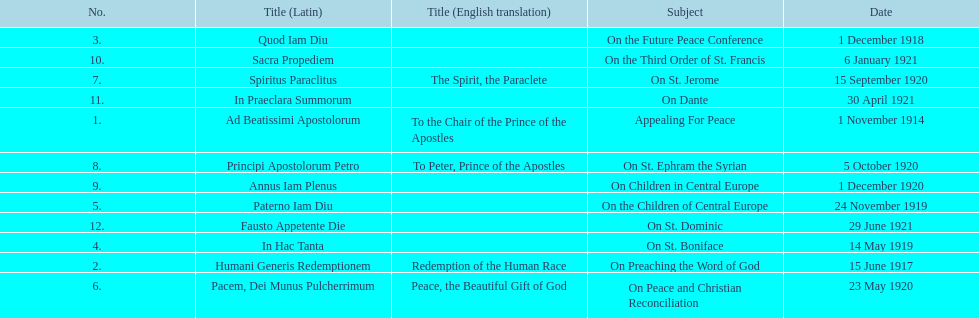What is the only subject on 23 may 1920? On Peace and Christian Reconciliation. 